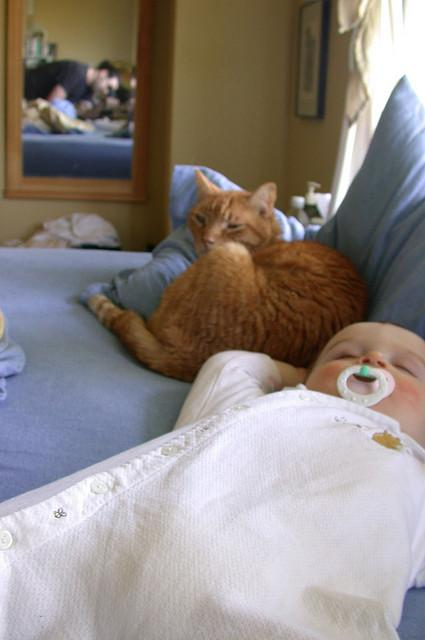How many different living creatures are visible here?

Choices:
A) three
B) zero
C) one
D) eight three 